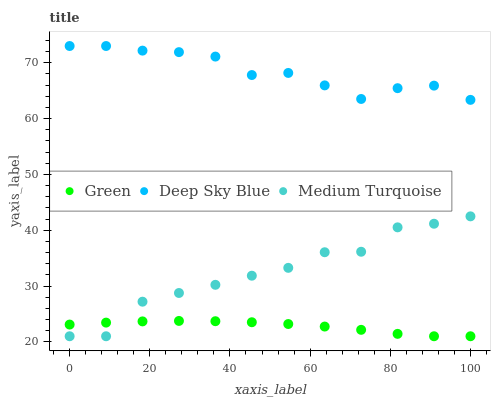Does Green have the minimum area under the curve?
Answer yes or no. Yes. Does Deep Sky Blue have the maximum area under the curve?
Answer yes or no. Yes. Does Medium Turquoise have the minimum area under the curve?
Answer yes or no. No. Does Medium Turquoise have the maximum area under the curve?
Answer yes or no. No. Is Green the smoothest?
Answer yes or no. Yes. Is Medium Turquoise the roughest?
Answer yes or no. Yes. Is Deep Sky Blue the smoothest?
Answer yes or no. No. Is Deep Sky Blue the roughest?
Answer yes or no. No. Does Green have the lowest value?
Answer yes or no. Yes. Does Deep Sky Blue have the lowest value?
Answer yes or no. No. Does Deep Sky Blue have the highest value?
Answer yes or no. Yes. Does Medium Turquoise have the highest value?
Answer yes or no. No. Is Medium Turquoise less than Deep Sky Blue?
Answer yes or no. Yes. Is Deep Sky Blue greater than Green?
Answer yes or no. Yes. Does Medium Turquoise intersect Green?
Answer yes or no. Yes. Is Medium Turquoise less than Green?
Answer yes or no. No. Is Medium Turquoise greater than Green?
Answer yes or no. No. Does Medium Turquoise intersect Deep Sky Blue?
Answer yes or no. No. 